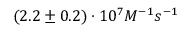Convert formula to latex. <formula><loc_0><loc_0><loc_500><loc_500>( 2 . 2 \pm 0 . 2 ) \cdot 1 0 ^ { 7 } M ^ { - 1 } s ^ { - 1 }</formula> 